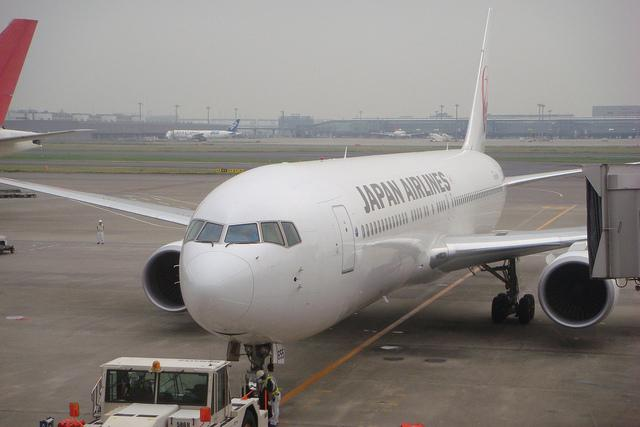What is the official language of this airline's country?

Choices:
A) japanese
B) chinese
C) korean
D) russian japanese 